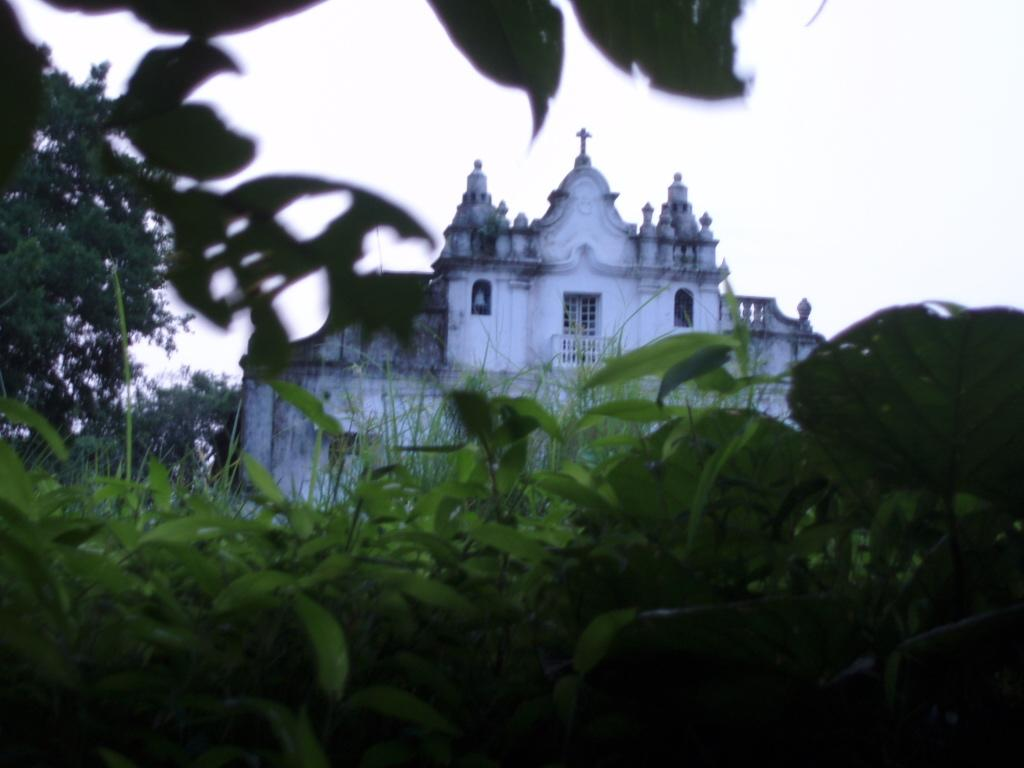Where was the image taken? The image was clicked outside. What can be seen in the foreground of the image? There are plants in the foreground of the image. What is the main structure visible in the image? There is a building in the center of the image. What is visible in the background of the image? The sky and trees are visible in the background of the image. What are the firemen doing in the image? There are no firemen present in the image. 